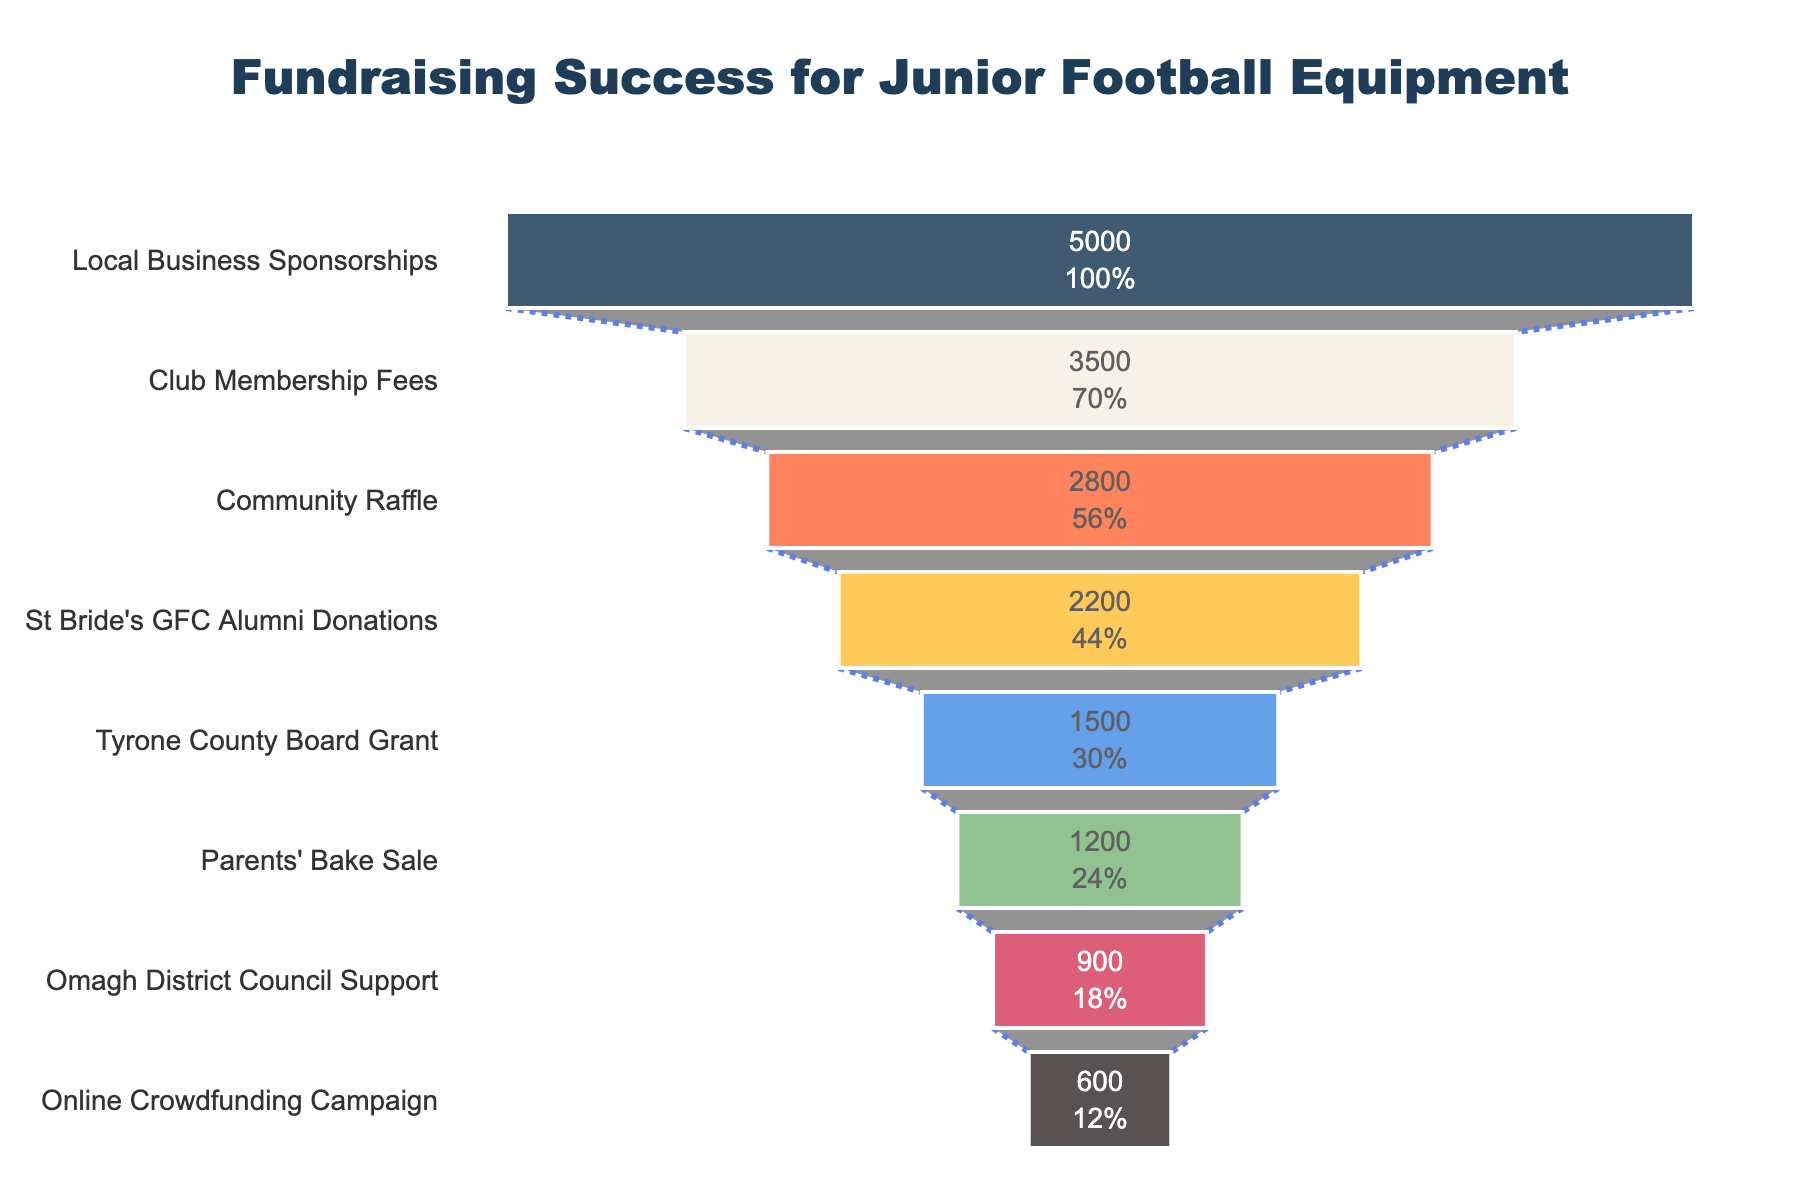What is the title of the funnel chart? The title can be found at the top of the funnel chart, prominently displayed.
Answer: Fundraising Success for Junior Football Equipment Which funding source raised the most money? The largest segment at the top of the funnel indicates the highest amount raised.
Answer: Local Business Sponsorships How much did the community raffle raise? Look at the value labeled inside the funnel for the Community Raffle section.
Answer: £2800 What percentage of the total amount raised did St Bride's GFC Alumni Donations contribute? The percentage is indicated inside the section of the funnel corresponding to St Bride's GFC Alumni Donations.
Answer: 10% What is the sum of the funds raised by the Parents' Bake Sale and Omagh District Council Support? Add the amounts from the Parents' Bake Sale (£1200) and Omagh District Council Support (£900).
Answer: £2100 Compare the funds raised by Club Membership Fees to St Bride's GFC Alumni Donations. Which raised more and by how much? Subtract the amount raised by St Bride's GFC Alumni Donations from the amount raised by Club Membership Fees. (£3500 - £2200)
Answer: Club Membership Fees raised £1300 more How many funding sources raised more than £2000? Count the sections of the funnel chart where the amount raised is greater than £2000.
Answer: 3 Which funding source is immediately below the Community Raffle in the funnel? Identify the next section of the funnel below the Community Raffle segment.
Answer: St Bride's GFC Alumni Donations What is the median amount raised across all funding sources? List all amounts, then find the middle value. (Sorted: £600, £900, £1200, £1500, £2200, £2800, £3500, £5000; Median: average of £1500 and £2200) (£1500+£2200)/2
Answer: £1850 If the goal was to raise £20,000, what percentage of the goal was achieved? Sum the amounts raised, then divide by the goal and multiply by 100. (Total raised: £17700, Goal: £20000) (17700/20000)*100
Answer: 88.5% 